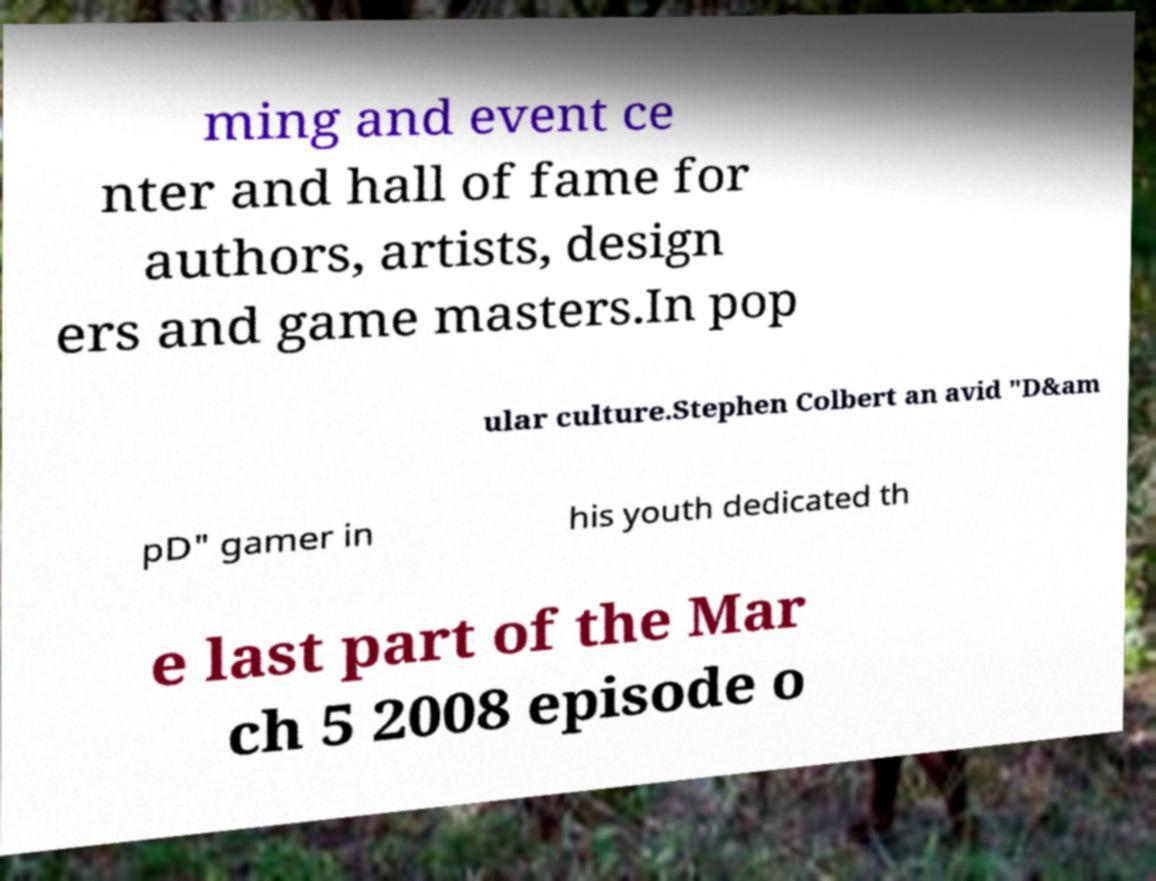Please identify and transcribe the text found in this image. ming and event ce nter and hall of fame for authors, artists, design ers and game masters.In pop ular culture.Stephen Colbert an avid "D&am pD" gamer in his youth dedicated th e last part of the Mar ch 5 2008 episode o 